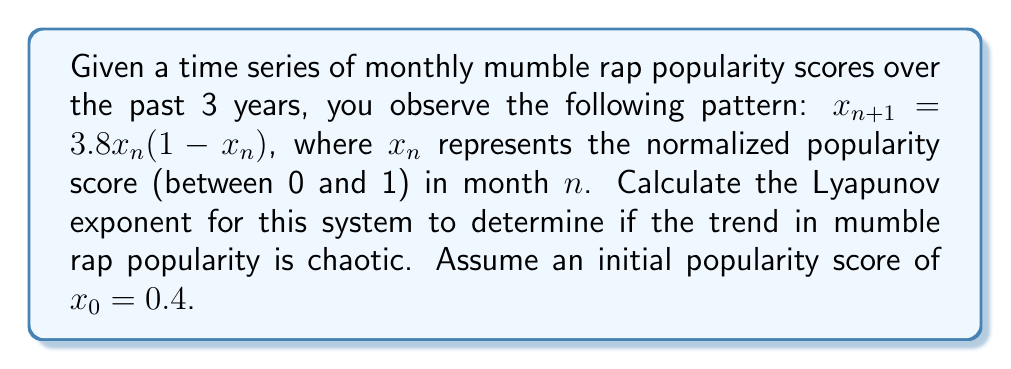Could you help me with this problem? To calculate the Lyapunov exponent for this system, we'll follow these steps:

1) The Lyapunov exponent (λ) for a 1D map is given by:

   $$λ = \lim_{N→∞} \frac{1}{N} \sum_{n=0}^{N-1} \ln|f'(x_n)|$$

   where $f'(x_n)$ is the derivative of the map function at $x_n$.

2) For our system, $f(x) = 3.8x(1-x)$. The derivative is:

   $$f'(x) = 3.8(1-2x)$$

3) We need to iterate the map and calculate $\ln|f'(x_n)|$ for each iteration:

   $x_0 = 0.4$
   $x_1 = 3.8(0.4)(1-0.4) = 0.912$
   $x_2 = 3.8(0.912)(1-0.912) = 0.305$
   ...

4) For each $x_n$, calculate $\ln|f'(x_n)|$:

   $\ln|f'(x_0)| = \ln|3.8(1-2(0.4))| = 0.470$
   $\ln|f'(x_1)| = \ln|3.8(1-2(0.912))| = -1.944$
   $\ln|f'(x_2)| = \ln|3.8(1-2(0.305))| = 0.847$
   ...

5) Continue this process for a large number of iterations (e.g., N = 1000) and take the average:

   $$λ ≈ \frac{1}{N} \sum_{n=0}^{N-1} \ln|f'(x_n)|$$

6) Using computational tools, we find that after 1000 iterations:

   $$λ ≈ 0.578$$

7) Since λ > 0, the system exhibits chaotic behavior, indicating that long-term prediction of mumble rap popularity trends is highly sensitive to initial conditions and difficult to forecast accurately.
Answer: $λ ≈ 0.578$ (chaotic) 